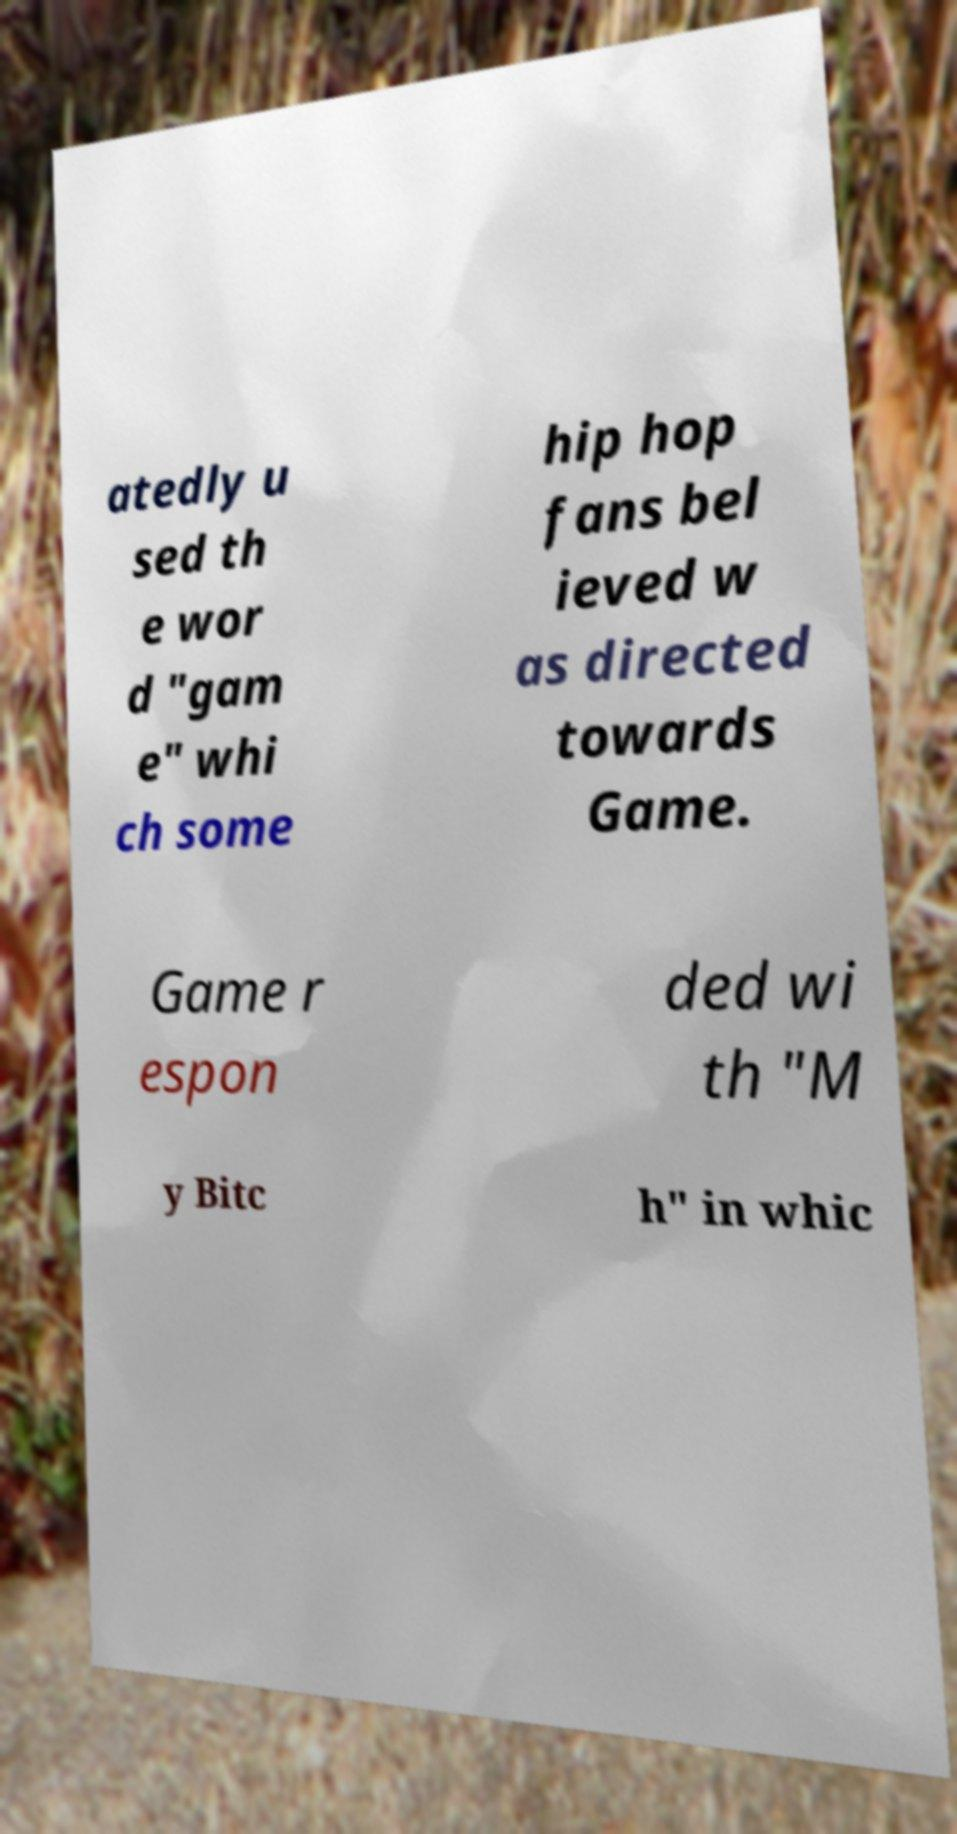Could you assist in decoding the text presented in this image and type it out clearly? atedly u sed th e wor d "gam e" whi ch some hip hop fans bel ieved w as directed towards Game. Game r espon ded wi th "M y Bitc h" in whic 